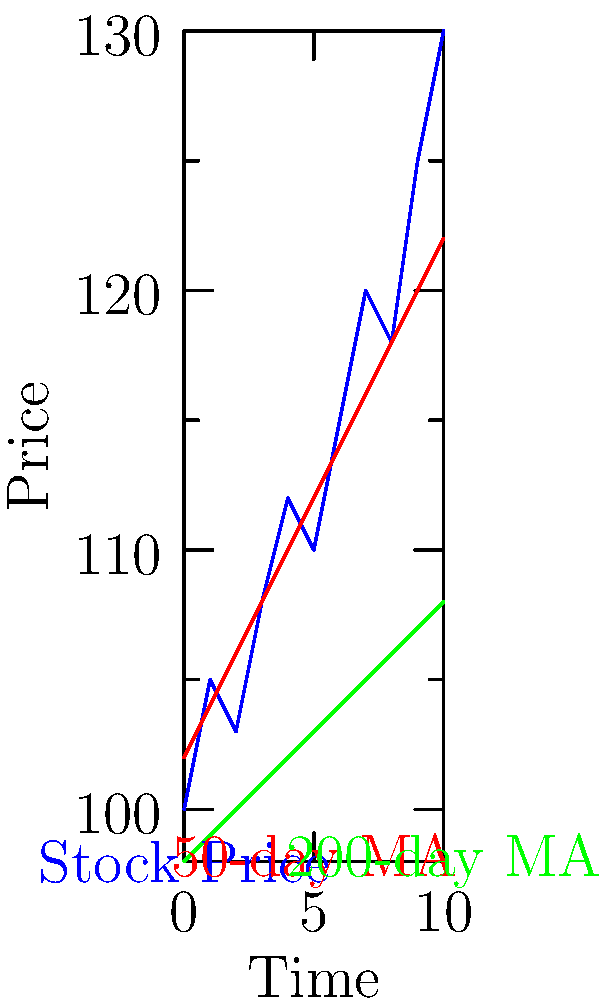Based on the historical stock price chart shown, which of the following statements best describes the overall trend and potential trading signals?

A) The stock is in a downtrend, and the 50-day moving average is about to cross below the 200-day moving average, signaling a potential sell.
B) The stock is in an uptrend, and the 50-day moving average has recently crossed above the 200-day moving average, indicating a potential buy signal.
C) The stock is range-bound, with no clear trend, and the moving averages are parallel, suggesting no clear trading signal.
D) The stock is in a strong uptrend, but the moving averages have not crossed, indicating a potential upcoming correction. To interpret this historical stock price chart with moving averages, let's analyze it step by step:

1. Overall trend: The blue line representing the stock price shows a clear upward trajectory from left to right, indicating an uptrend.

2. 50-day Moving Average (MA): The red line represents the 50-day MA, which is above the 200-day MA and moving upward, confirming the uptrend.

3. 200-day Moving Average: The green line represents the 200-day MA, which is also moving upward but at a slower pace than the 50-day MA.

4. Moving Average Crossover: We can observe that the 50-day MA has crossed above the 200-day MA relatively recently (towards the left side of the chart). This crossover is known as a "Golden Cross" and is generally considered a bullish signal.

5. Price in relation to MAs: The stock price (blue line) is consistently above both moving averages, which is another bullish indication.

6. Slope of MAs: Both moving averages have positive slopes, further confirming the uptrend.

Given these observations, the statement that best describes the situation is option B. The stock is in an uptrend, and the 50-day moving average has recently crossed above the 200-day moving average, indicating a potential buy signal.

This interpretation aligns with the persona of an investment advisor who uses historical market data to guide investment strategies, as it relies on well-established technical analysis principles.
Answer: B) The stock is in an uptrend, and the 50-day moving average has recently crossed above the 200-day moving average, indicating a potential buy signal. 